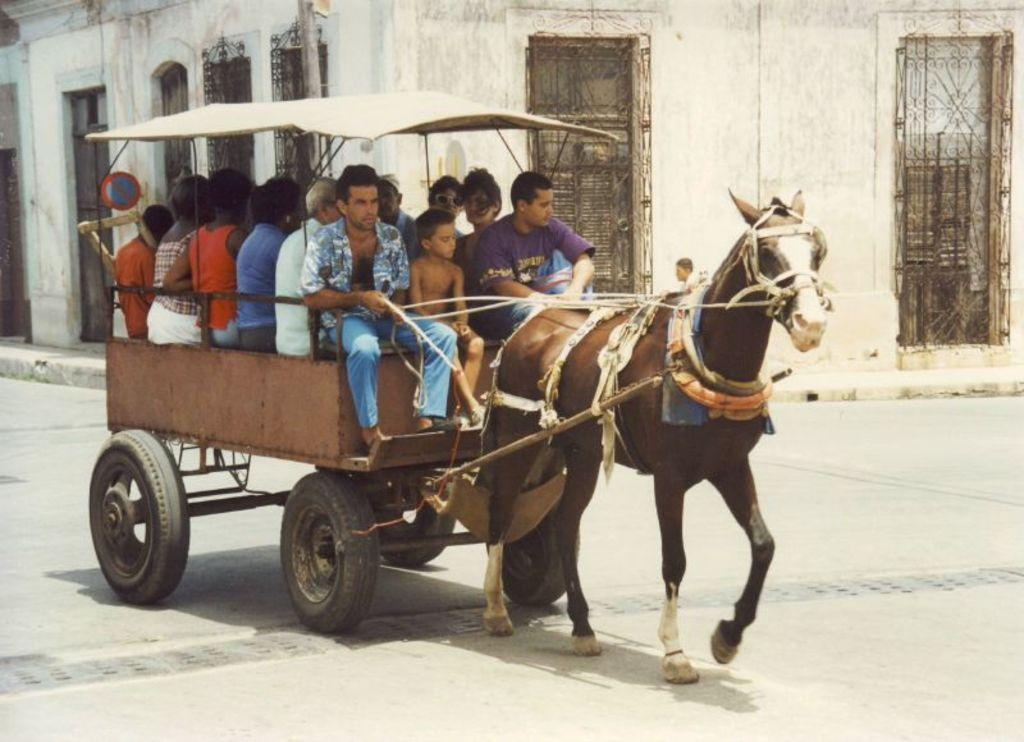What are the people in the image doing? The people in the image are seated on a vehicle. How is the vehicle being transported? The vehicle is carried by a horse. What can be seen in the background of the image? There is a sign board and a building in the background of the image. What type of bells are the people wearing in the image? There are no bells visible on the people in the image. 